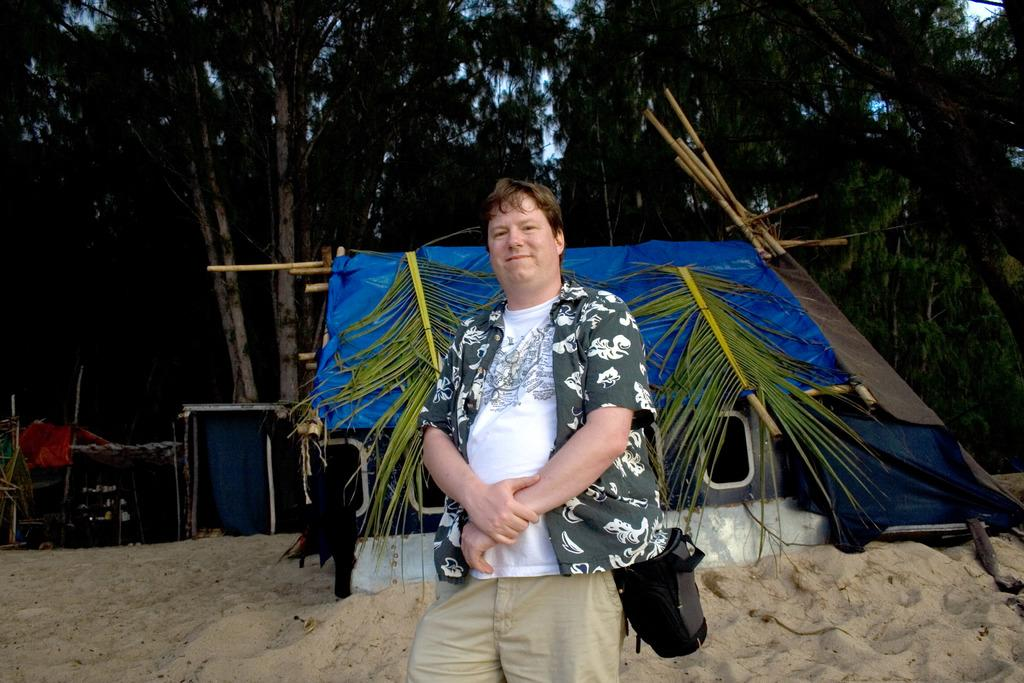What is the man in the image doing? The man is standing in the image. What is the man carrying in the image? The man is carrying a bag. What type of terrain is visible in the image? There is sand visible in the image. What type of vegetation is present in the image? There are leaves and trees in the image. What type of structures can be seen in the image? There are sheds in the image. What else can be seen in the image? There are objects in the image. What is visible in the background of the image? The sky is visible in the background of the image. What type of alarm is going off in the image? There is no alarm present in the image. What kind of oatmeal is being served in the image? There is no oatmeal present in the image. 